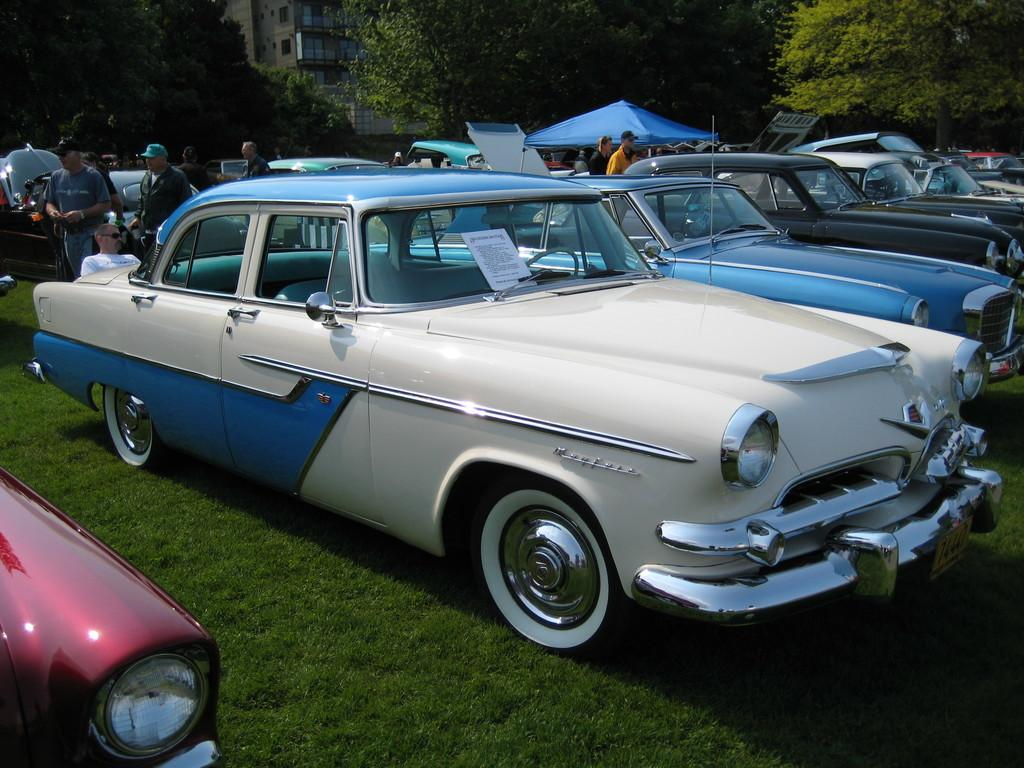What is the main subject of the image? The main subject of the image is many cars. Can you describe the people in the image? There are people between the cars in the image. What can be seen in the background of the image? There are trees and a building in the background of the image. What type of rose is growing on the hood of the car in the image? There is no rose present on any of the cars in the image. 